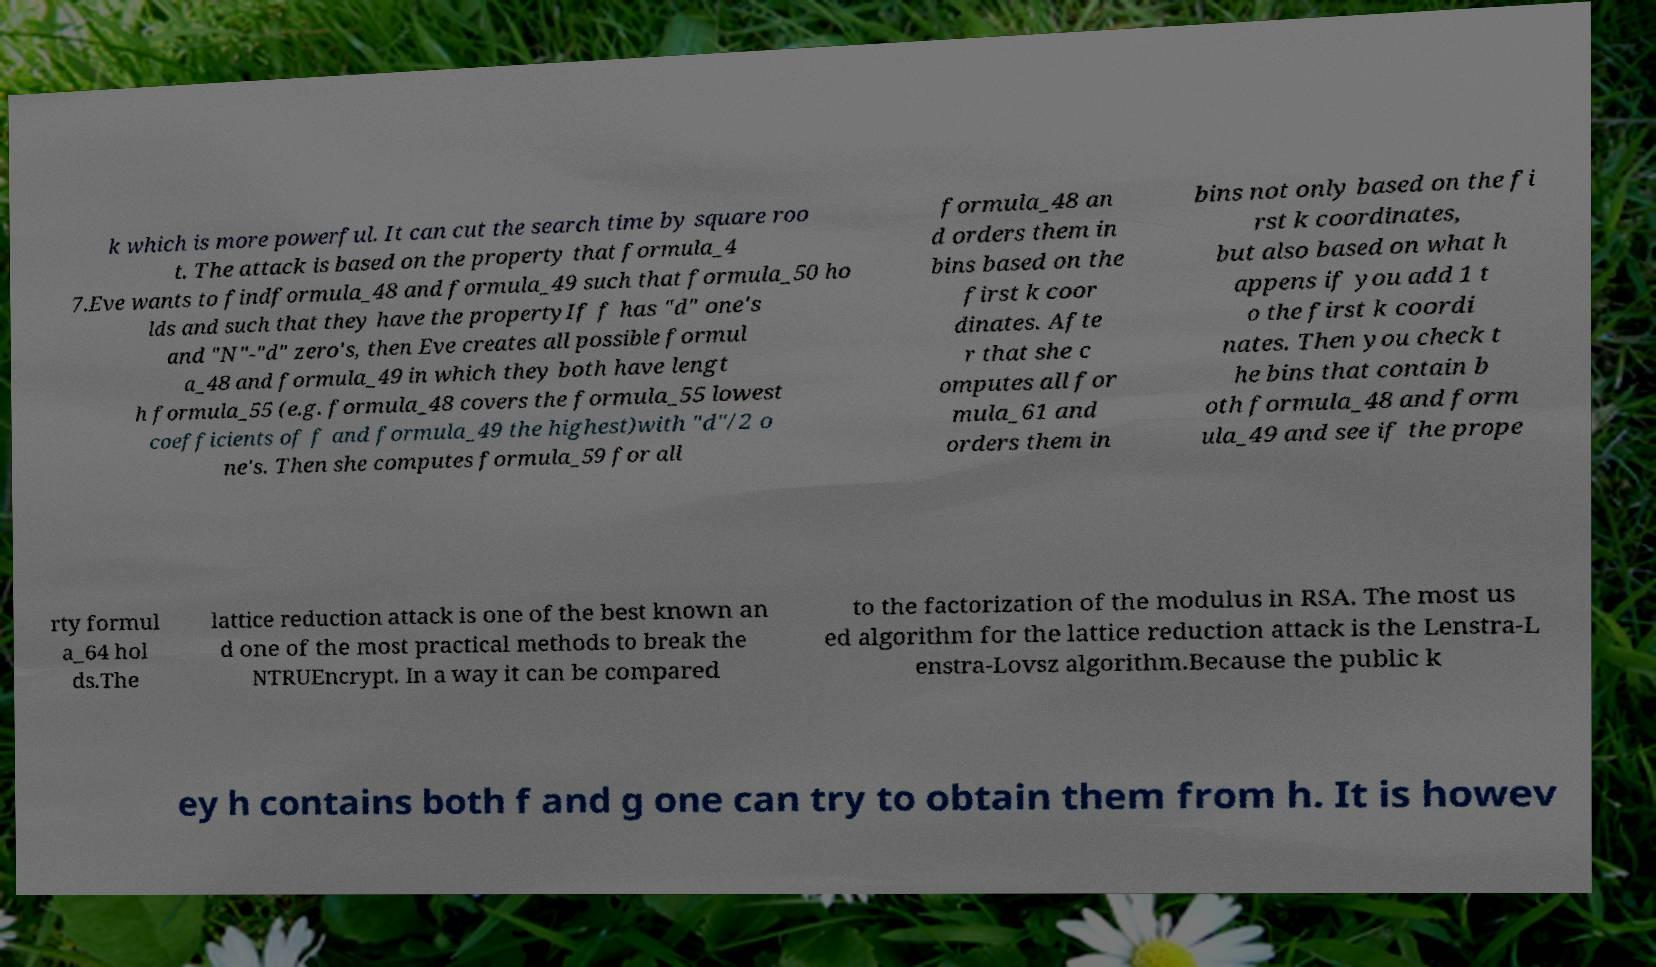There's text embedded in this image that I need extracted. Can you transcribe it verbatim? k which is more powerful. It can cut the search time by square roo t. The attack is based on the property that formula_4 7.Eve wants to findformula_48 and formula_49 such that formula_50 ho lds and such that they have the propertyIf f has "d" one's and "N"-"d" zero's, then Eve creates all possible formul a_48 and formula_49 in which they both have lengt h formula_55 (e.g. formula_48 covers the formula_55 lowest coefficients of f and formula_49 the highest)with "d"/2 o ne's. Then she computes formula_59 for all formula_48 an d orders them in bins based on the first k coor dinates. Afte r that she c omputes all for mula_61 and orders them in bins not only based on the fi rst k coordinates, but also based on what h appens if you add 1 t o the first k coordi nates. Then you check t he bins that contain b oth formula_48 and form ula_49 and see if the prope rty formul a_64 hol ds.The lattice reduction attack is one of the best known an d one of the most practical methods to break the NTRUEncrypt. In a way it can be compared to the factorization of the modulus in RSA. The most us ed algorithm for the lattice reduction attack is the Lenstra-L enstra-Lovsz algorithm.Because the public k ey h contains both f and g one can try to obtain them from h. It is howev 